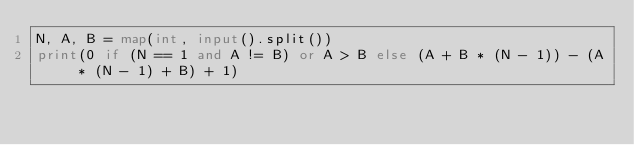<code> <loc_0><loc_0><loc_500><loc_500><_Python_>N, A, B = map(int, input().split())
print(0 if (N == 1 and A != B) or A > B else (A + B * (N - 1)) - (A * (N - 1) + B) + 1)</code> 